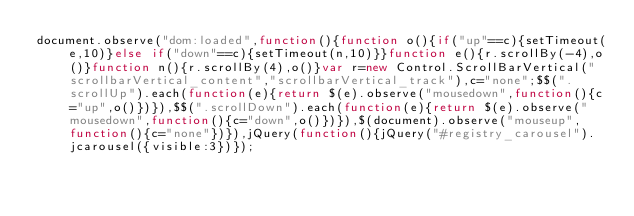<code> <loc_0><loc_0><loc_500><loc_500><_JavaScript_>document.observe("dom:loaded",function(){function o(){if("up"==c){setTimeout(e,10)}else if("down"==c){setTimeout(n,10)}}function e(){r.scrollBy(-4),o()}function n(){r.scrollBy(4),o()}var r=new Control.ScrollBarVertical("scrollbarVertical_content","scrollbarVertical_track"),c="none";$$(".scrollUp").each(function(e){return $(e).observe("mousedown",function(){c="up",o()})}),$$(".scrollDown").each(function(e){return $(e).observe("mousedown",function(){c="down",o()})}),$(document).observe("mouseup",function(){c="none"})}),jQuery(function(){jQuery("#registry_carousel").jcarousel({visible:3})});</code> 